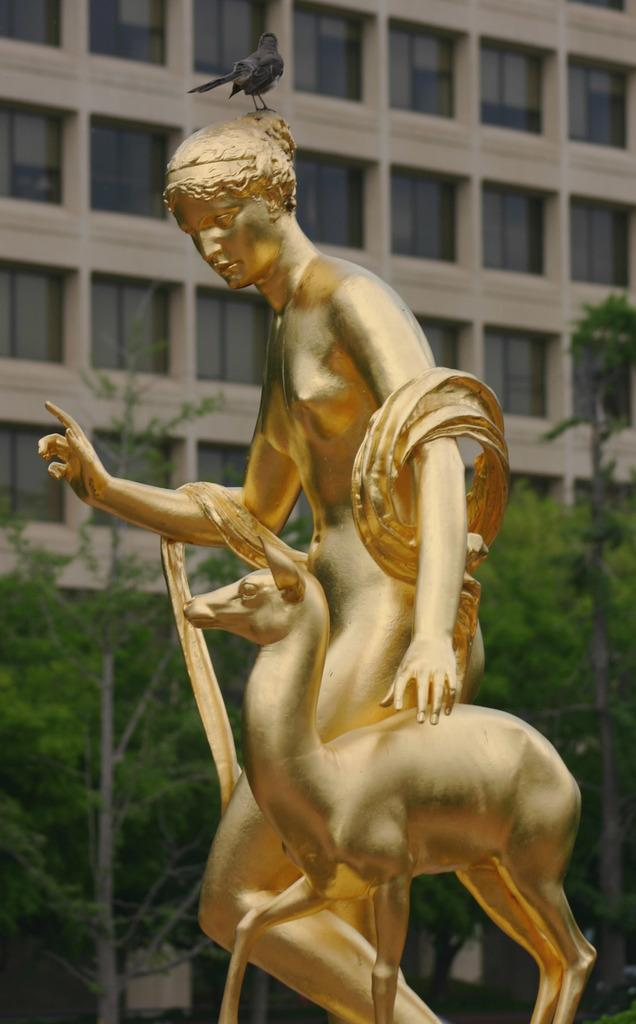What can be seen in the image besides the trees and building in the background? There are statues of a woman and an animal in the image, and a bird is on the head of the woman statue. What type of animal is depicted in the statue? The specific type of animal is not mentioned, but it is a statue of an animal alongside a statue of a woman. What is the bird doing on the woman statue? The bird is perched on the head of the woman statue. How does the woman statue play volleyball in the image? The woman statue is not playing volleyball in the image; it is a statue of a woman with a bird on its head. What is the comparison between the push of the animal statue and the bird on the woman statue? There is no comparison being made between the push of the animal statue and the bird on the woman statue, as the facts provided do not mention any pushing or comparison. 